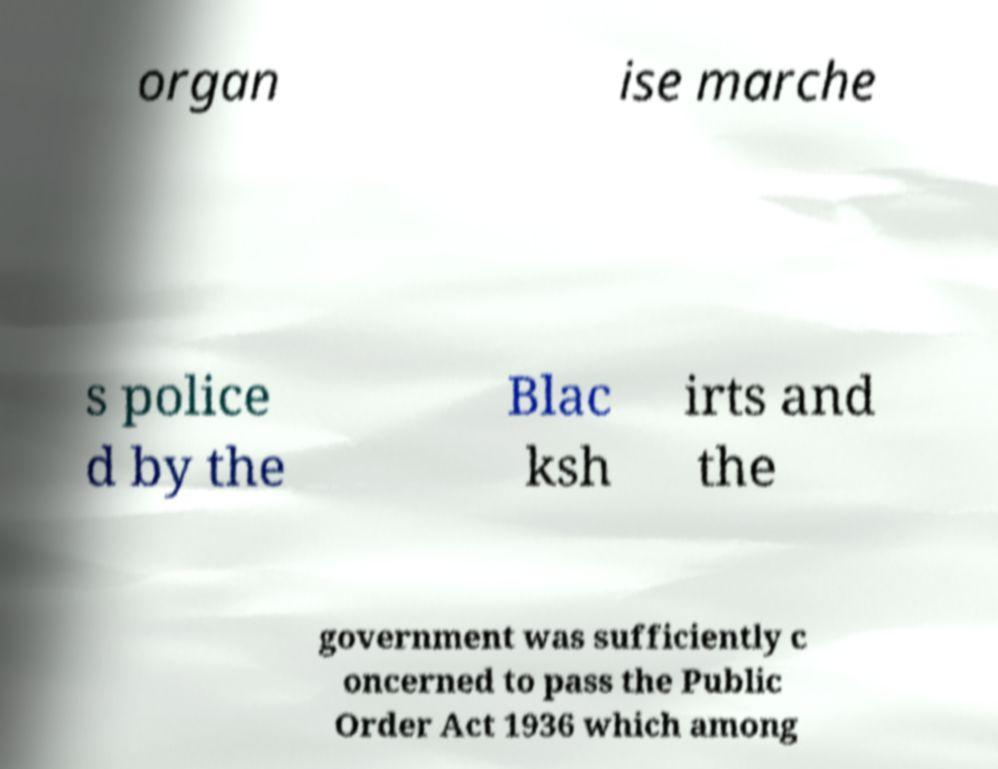For documentation purposes, I need the text within this image transcribed. Could you provide that? organ ise marche s police d by the Blac ksh irts and the government was sufficiently c oncerned to pass the Public Order Act 1936 which among 